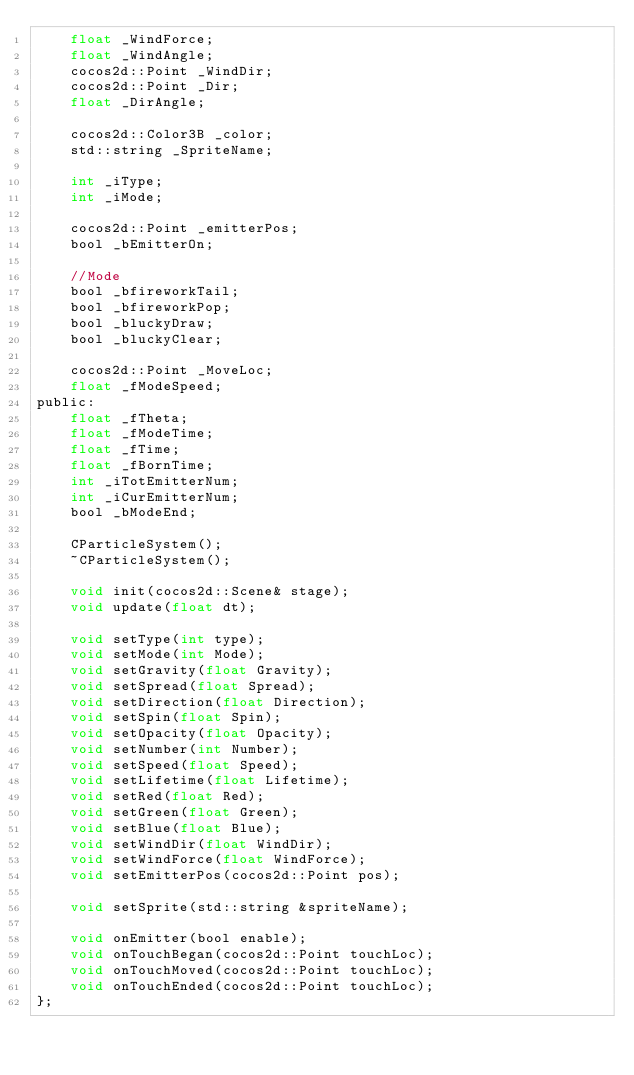Convert code to text. <code><loc_0><loc_0><loc_500><loc_500><_C_>	float _WindForce;
	float _WindAngle;
	cocos2d::Point _WindDir;
	cocos2d::Point _Dir;
	float _DirAngle;

	cocos2d::Color3B _color;
	std::string _SpriteName;

	int _iType;
	int _iMode;

	cocos2d::Point _emitterPos;
	bool _bEmitterOn;

	//Mode
	bool _bfireworkTail;
	bool _bfireworkPop;
	bool _bluckyDraw;
	bool _bluckyClear;

	cocos2d::Point _MoveLoc;
	float _fModeSpeed;
public:
	float _fTheta;
	float _fModeTime;
	float _fTime;
	float _fBornTime;
	int _iTotEmitterNum;
	int _iCurEmitterNum;
	bool _bModeEnd;

	CParticleSystem();
	~CParticleSystem();

	void init(cocos2d::Scene& stage);
	void update(float dt);

	void setType(int type);
	void setMode(int Mode);
	void setGravity(float Gravity);
	void setSpread(float Spread);
	void setDirection(float Direction);
	void setSpin(float Spin);
	void setOpacity(float Opacity);
	void setNumber(int Number);
	void setSpeed(float Speed);
	void setLifetime(float Lifetime);
	void setRed(float Red);
	void setGreen(float Green);
	void setBlue(float Blue);
	void setWindDir(float WindDir);
	void setWindForce(float WindForce);
	void setEmitterPos(cocos2d::Point pos);

	void setSprite(std::string &spriteName);

	void onEmitter(bool enable);
	void onTouchBegan(cocos2d::Point touchLoc); 
	void onTouchMoved(cocos2d::Point touchLoc);
	void onTouchEnded(cocos2d::Point touchLoc);
};</code> 